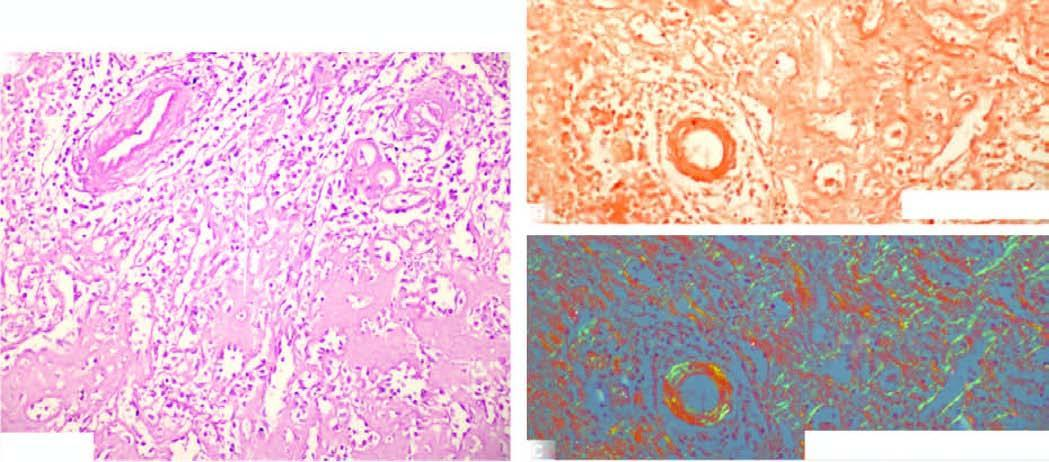s sectioned slice of the liver seen in the red pulp causing atrophy of while pulp?
Answer the question using a single word or phrase. No 